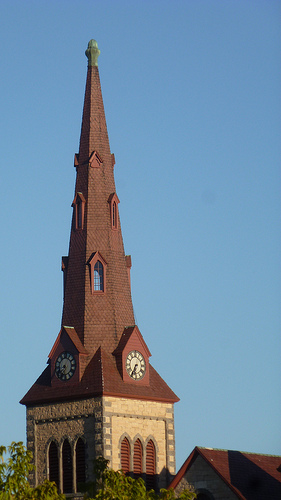How many clocks are there? 2 